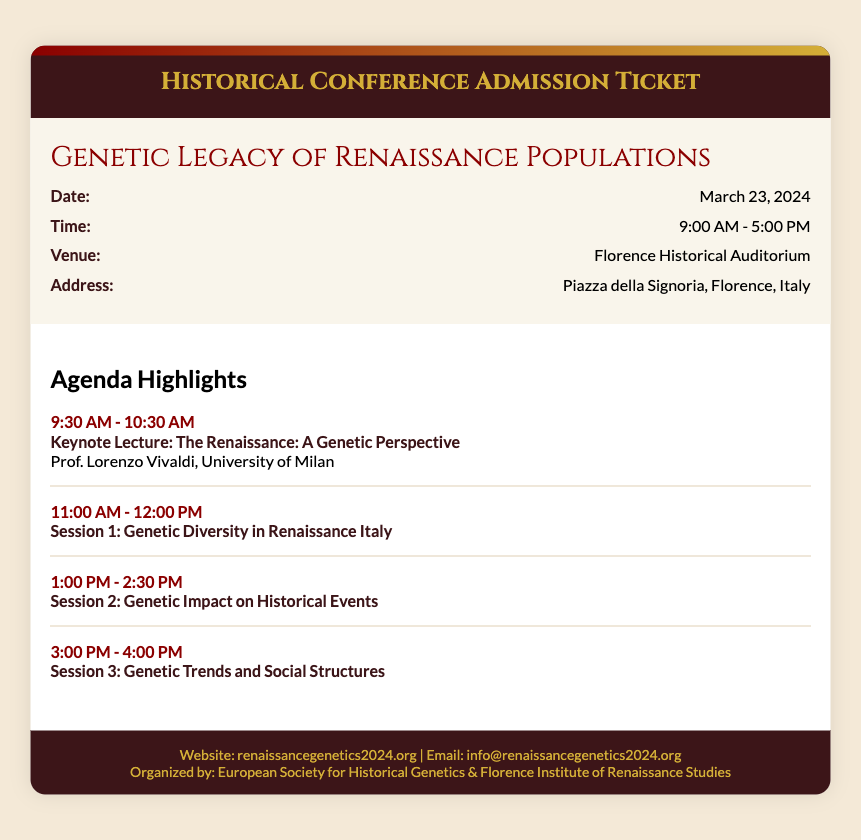What is the event name? The event name is clearly stated in the document under the event details section.
Answer: Genetic Legacy of Renaissance Populations What is the date of the conference? The date is listed in the information row under event details.
Answer: March 23, 2024 What time does the conference start? The starting time is specified in the document's event details section.
Answer: 9:00 AM Where is the conference venue located? The venue information is provided in the details section of the ticket.
Answer: Florence Historical Auditorium Who is giving the keynote lecture? The keynote lecturer is mentioned in the agenda section with their affiliation.
Answer: Prof. Lorenzo Vivaldi What is the topic of Session 2? The topic of Session 2 is presented in the agenda highlights section.
Answer: Genetic Impact on Historical Events What organization is organizing the conference? The organizing body is specified at the bottom of the document.
Answer: European Society for Historical Genetics & Florence Institute of Renaissance Studies How long is the conference scheduled to last? The end time suggests the total duration between the start and end times.
Answer: 8 hours 